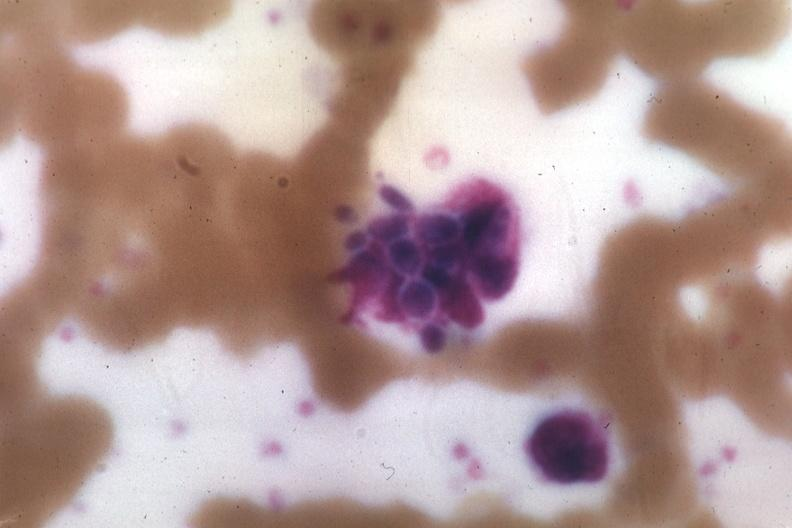s rocky mountain present?
Answer the question using a single word or phrase. No 